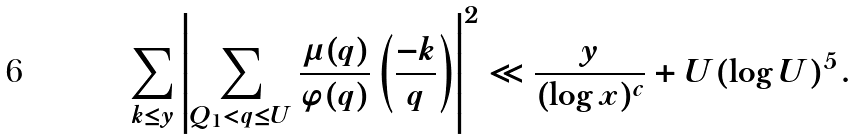<formula> <loc_0><loc_0><loc_500><loc_500>\sum _ { k \leq y } \left | \sum _ { Q _ { 1 } < q \leq U } \frac { \mu ( q ) } { \varphi ( q ) } \left ( \frac { - k } { q } \right ) \right | ^ { 2 } \ll \frac { y } { ( \log x ) ^ { c } } + U ( \log U ) ^ { 5 } .</formula> 